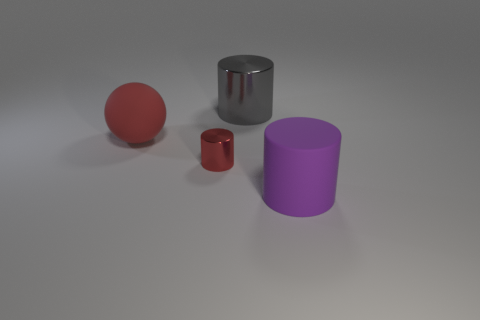What might be the purpose of these objects? The objects in the image seem to be simplistic models used for various purposes such as graphical rendering tests, physical simulations, or educational demonstrations in geometry. They each represent fundamental geometric shapes: spheres and cylinders. The objects' lack of additional features or context suggests they are not intended for practical use but rather for illustrative or testing purposes. 